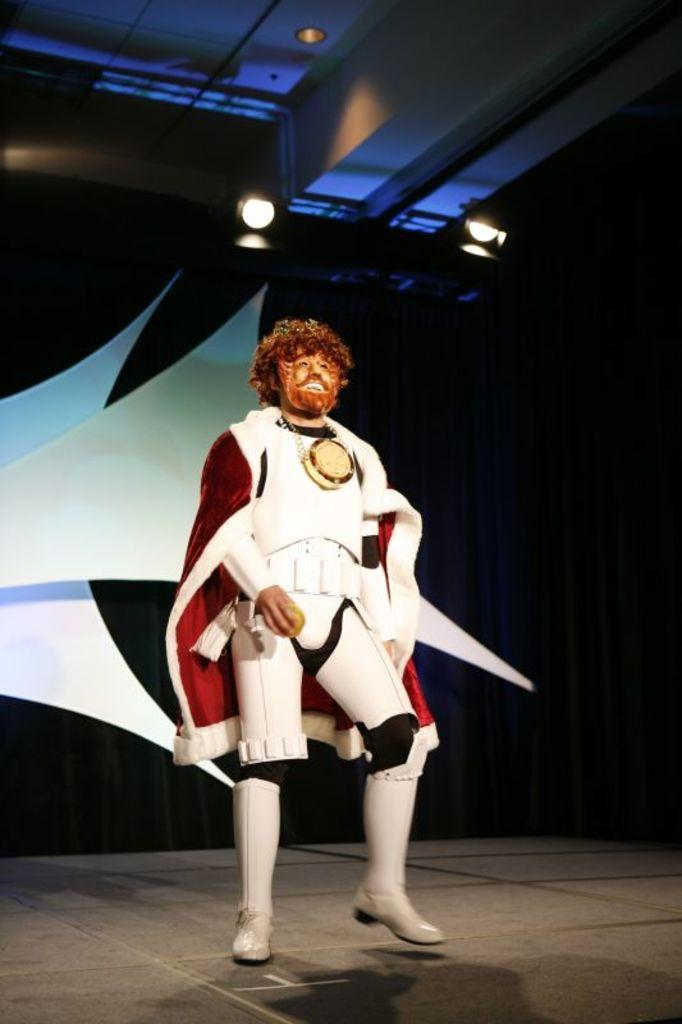Who or what is the main subject in the image? There is a person in the image. What is the person wearing? The person is wearing a white costume. What can be seen in the background of the image? There is a black and white background in the image. What is located at the top of the image? There are lights on the top of the image. What type of secretary can be seen working in the image? There is no secretary present in the image; it features a person wearing a white costume. How many ducks are visible in the image? There are no ducks present in the image. 